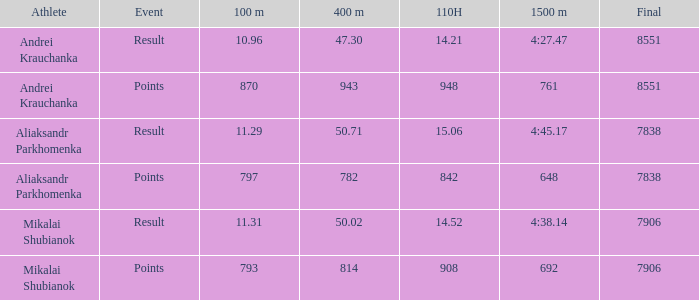Considering mikalai shubianok had a score of 110h less than 908, what was his ultimate outcome? 7906.0. 